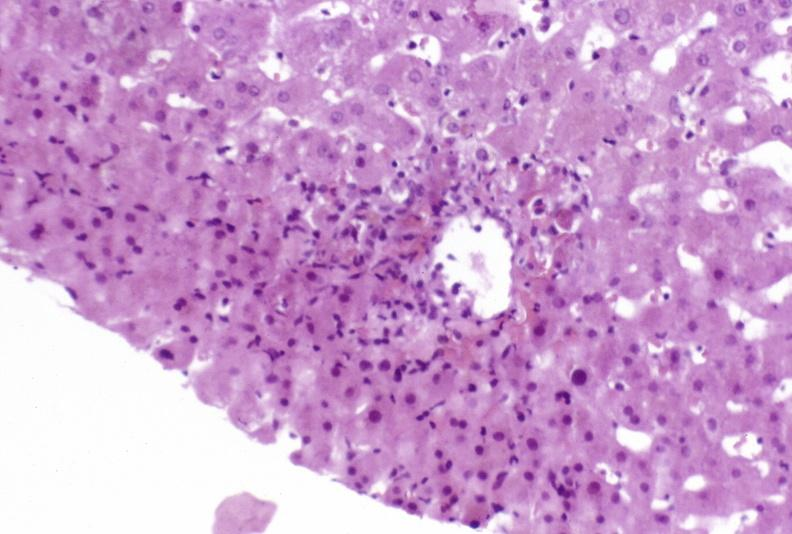does hemisection of nose show moderate acute rejection?
Answer the question using a single word or phrase. No 